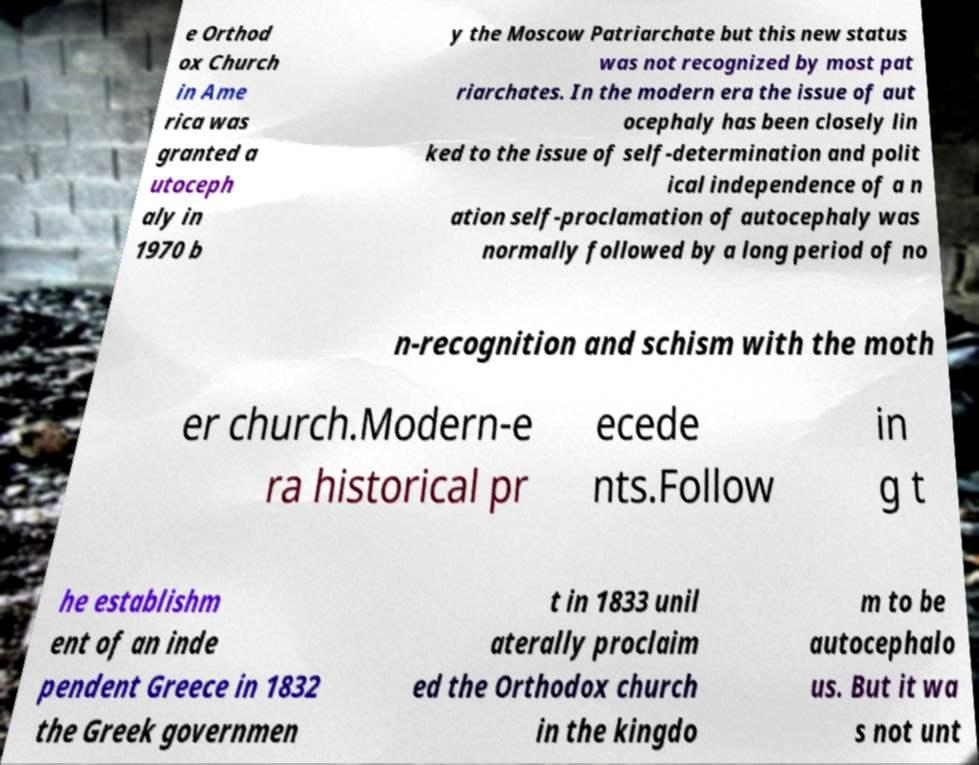Could you extract and type out the text from this image? e Orthod ox Church in Ame rica was granted a utoceph aly in 1970 b y the Moscow Patriarchate but this new status was not recognized by most pat riarchates. In the modern era the issue of aut ocephaly has been closely lin ked to the issue of self-determination and polit ical independence of a n ation self-proclamation of autocephaly was normally followed by a long period of no n-recognition and schism with the moth er church.Modern-e ra historical pr ecede nts.Follow in g t he establishm ent of an inde pendent Greece in 1832 the Greek governmen t in 1833 unil aterally proclaim ed the Orthodox church in the kingdo m to be autocephalo us. But it wa s not unt 